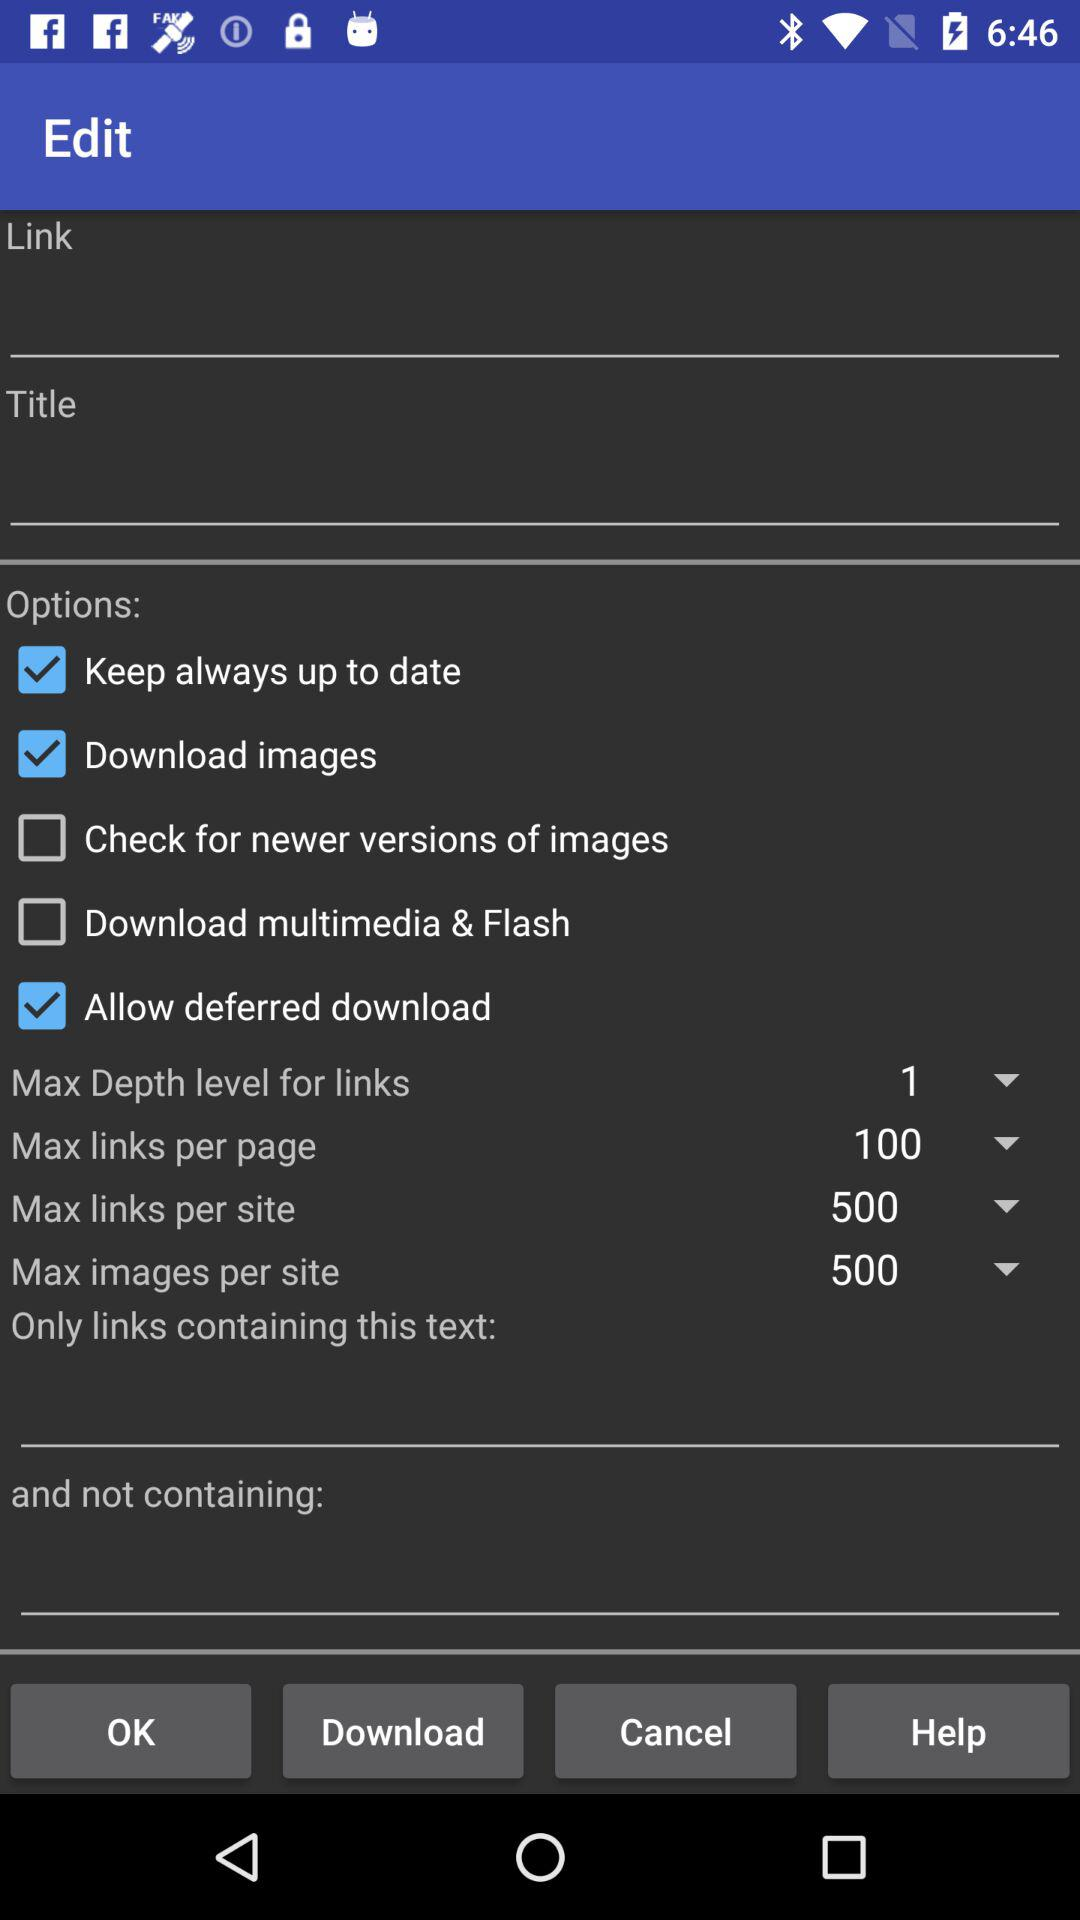What is the maximum number of links per page? The maximum number of links per page is 100. 